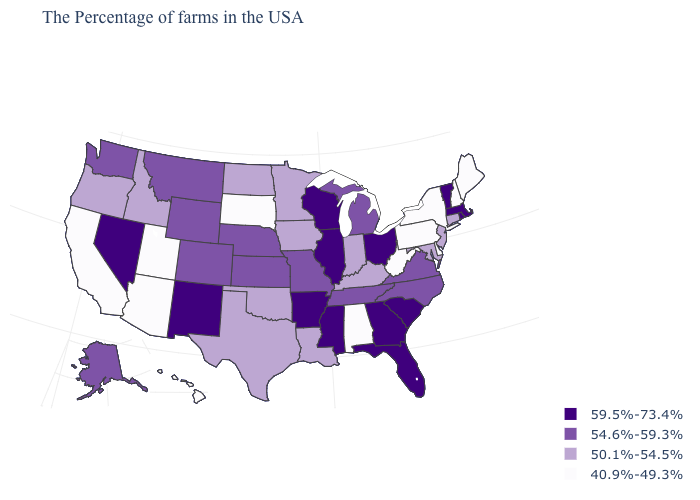What is the value of South Carolina?
Give a very brief answer. 59.5%-73.4%. What is the value of Ohio?
Quick response, please. 59.5%-73.4%. What is the value of Michigan?
Short answer required. 54.6%-59.3%. Which states have the lowest value in the USA?
Give a very brief answer. Maine, New Hampshire, New York, Delaware, Pennsylvania, West Virginia, Alabama, South Dakota, Utah, Arizona, California, Hawaii. Among the states that border New Jersey , which have the highest value?
Short answer required. New York, Delaware, Pennsylvania. What is the value of Missouri?
Answer briefly. 54.6%-59.3%. Name the states that have a value in the range 59.5%-73.4%?
Quick response, please. Massachusetts, Rhode Island, Vermont, South Carolina, Ohio, Florida, Georgia, Wisconsin, Illinois, Mississippi, Arkansas, New Mexico, Nevada. Does Indiana have a higher value than North Dakota?
Short answer required. No. What is the highest value in states that border Ohio?
Concise answer only. 54.6%-59.3%. Among the states that border Wisconsin , does Illinois have the highest value?
Give a very brief answer. Yes. What is the lowest value in the USA?
Write a very short answer. 40.9%-49.3%. Which states hav the highest value in the Northeast?
Answer briefly. Massachusetts, Rhode Island, Vermont. Among the states that border Washington , which have the lowest value?
Short answer required. Idaho, Oregon. Does West Virginia have the highest value in the USA?
Write a very short answer. No. Among the states that border Rhode Island , which have the highest value?
Keep it brief. Massachusetts. 